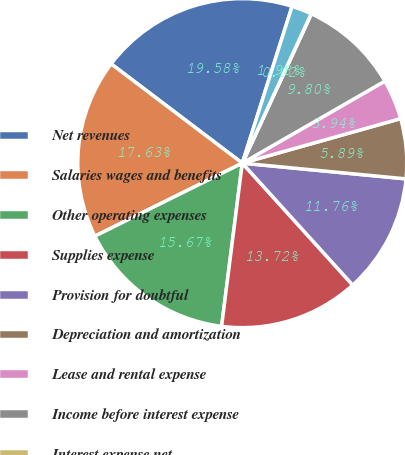<chart> <loc_0><loc_0><loc_500><loc_500><pie_chart><fcel>Net revenues<fcel>Salaries wages and benefits<fcel>Other operating expenses<fcel>Supplies expense<fcel>Provision for doubtful<fcel>Depreciation and amortization<fcel>Lease and rental expense<fcel>Income before interest expense<fcel>Interest expense net<fcel>Minority interests in earnings<nl><fcel>19.58%<fcel>17.63%<fcel>15.67%<fcel>13.72%<fcel>11.76%<fcel>5.89%<fcel>3.94%<fcel>9.8%<fcel>0.02%<fcel>1.98%<nl></chart> 